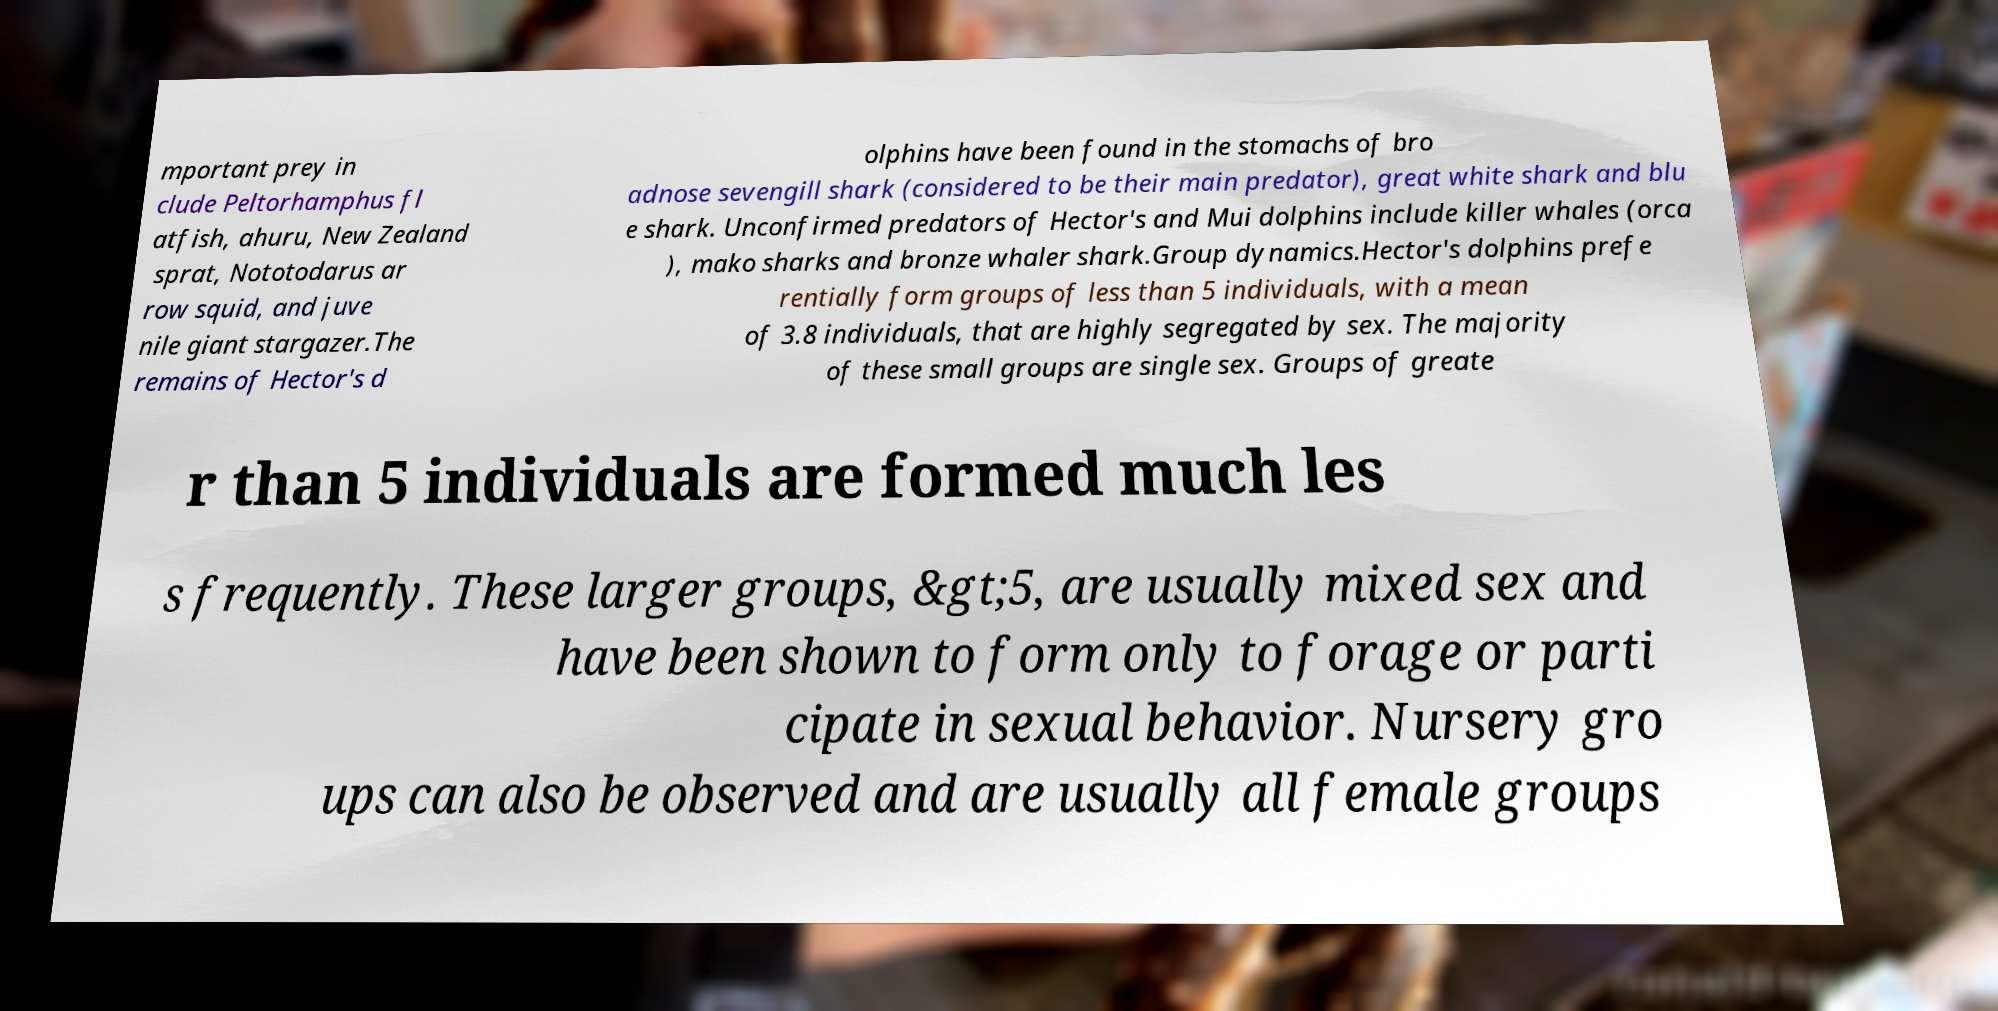Can you accurately transcribe the text from the provided image for me? mportant prey in clude Peltorhamphus fl atfish, ahuru, New Zealand sprat, Nototodarus ar row squid, and juve nile giant stargazer.The remains of Hector's d olphins have been found in the stomachs of bro adnose sevengill shark (considered to be their main predator), great white shark and blu e shark. Unconfirmed predators of Hector's and Mui dolphins include killer whales (orca ), mako sharks and bronze whaler shark.Group dynamics.Hector's dolphins prefe rentially form groups of less than 5 individuals, with a mean of 3.8 individuals, that are highly segregated by sex. The majority of these small groups are single sex. Groups of greate r than 5 individuals are formed much les s frequently. These larger groups, &gt;5, are usually mixed sex and have been shown to form only to forage or parti cipate in sexual behavior. Nursery gro ups can also be observed and are usually all female groups 